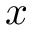Convert formula to latex. <formula><loc_0><loc_0><loc_500><loc_500>x</formula> 